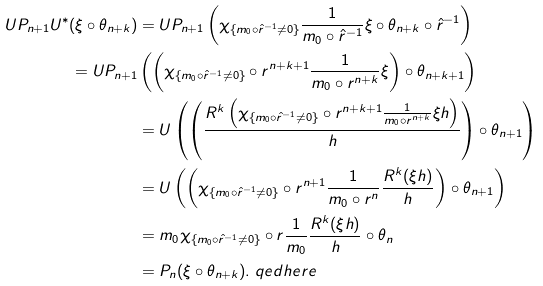Convert formula to latex. <formula><loc_0><loc_0><loc_500><loc_500>U P _ { n + 1 } U ^ { * } ( \xi \circ \theta _ { n + k } ) & = U P _ { n + 1 } \left ( \chi _ { \{ m _ { 0 } \circ \hat { r } ^ { - 1 } \neq 0 \} } \frac { 1 } { m _ { 0 } \circ \hat { r } ^ { - 1 } } \xi \circ \theta _ { n + k } \circ \hat { r } ^ { - 1 } \right ) \\ = U P _ { n + 1 } & \left ( \left ( \chi _ { \{ m _ { 0 } \circ \hat { r } ^ { - 1 } \neq 0 \} } \circ r ^ { n + k + 1 } \frac { 1 } { m _ { 0 } \circ r ^ { n + k } } \xi \right ) \circ \theta _ { n + k + 1 } \right ) \\ & = U \left ( \left ( \frac { R ^ { k } \left ( \chi _ { \{ m _ { 0 } \circ \hat { r } ^ { - 1 } \neq 0 \} } \circ r ^ { n + k + 1 } \frac { 1 } { m _ { 0 } \circ r ^ { n + k } } \xi h \right ) } { h } \right ) \circ \theta _ { n + 1 } \right ) \\ & = U \left ( \left ( \chi _ { \{ m _ { 0 } \circ \hat { r } ^ { - 1 } \neq 0 \} } \circ r ^ { n + 1 } \frac { 1 } { m _ { 0 } \circ r ^ { n } } \frac { R ^ { k } ( \xi h ) } { h } \right ) \circ \theta _ { n + 1 } \right ) \\ & = m _ { 0 } \chi _ { \{ m _ { 0 } \circ \hat { r } ^ { - 1 } \neq 0 \} } \circ r \frac { 1 } { m _ { 0 } } \frac { R ^ { k } ( \xi h ) } { h } \circ \theta _ { n } \\ & = P _ { n } ( \xi \circ \theta _ { n + k } ) . \ q e d h e r e</formula> 